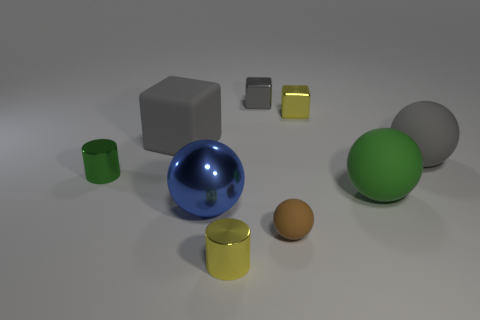Can you describe the shapes and sizes of objects in the image? Certainly, the image includes a mix of geometric shapes. There's a large blue sphere, a smaller green cylinder, a brown sphere of medium size, a large gray cube, a smaller gold cube, and two cylinders—one green and the other yellow—with the yellow cylinder being smaller and the only object with a metallic sheen. 